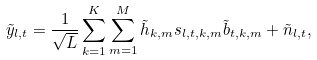Convert formula to latex. <formula><loc_0><loc_0><loc_500><loc_500>\tilde { y } _ { l , t } = \frac { 1 } { \sqrt { L } } \sum _ { k = 1 } ^ { K } \sum _ { m = 1 } ^ { M } \tilde { h } _ { k , m } s _ { l , t , k , m } \tilde { b } _ { t , k , m } + \tilde { n } _ { l , t } ,</formula> 